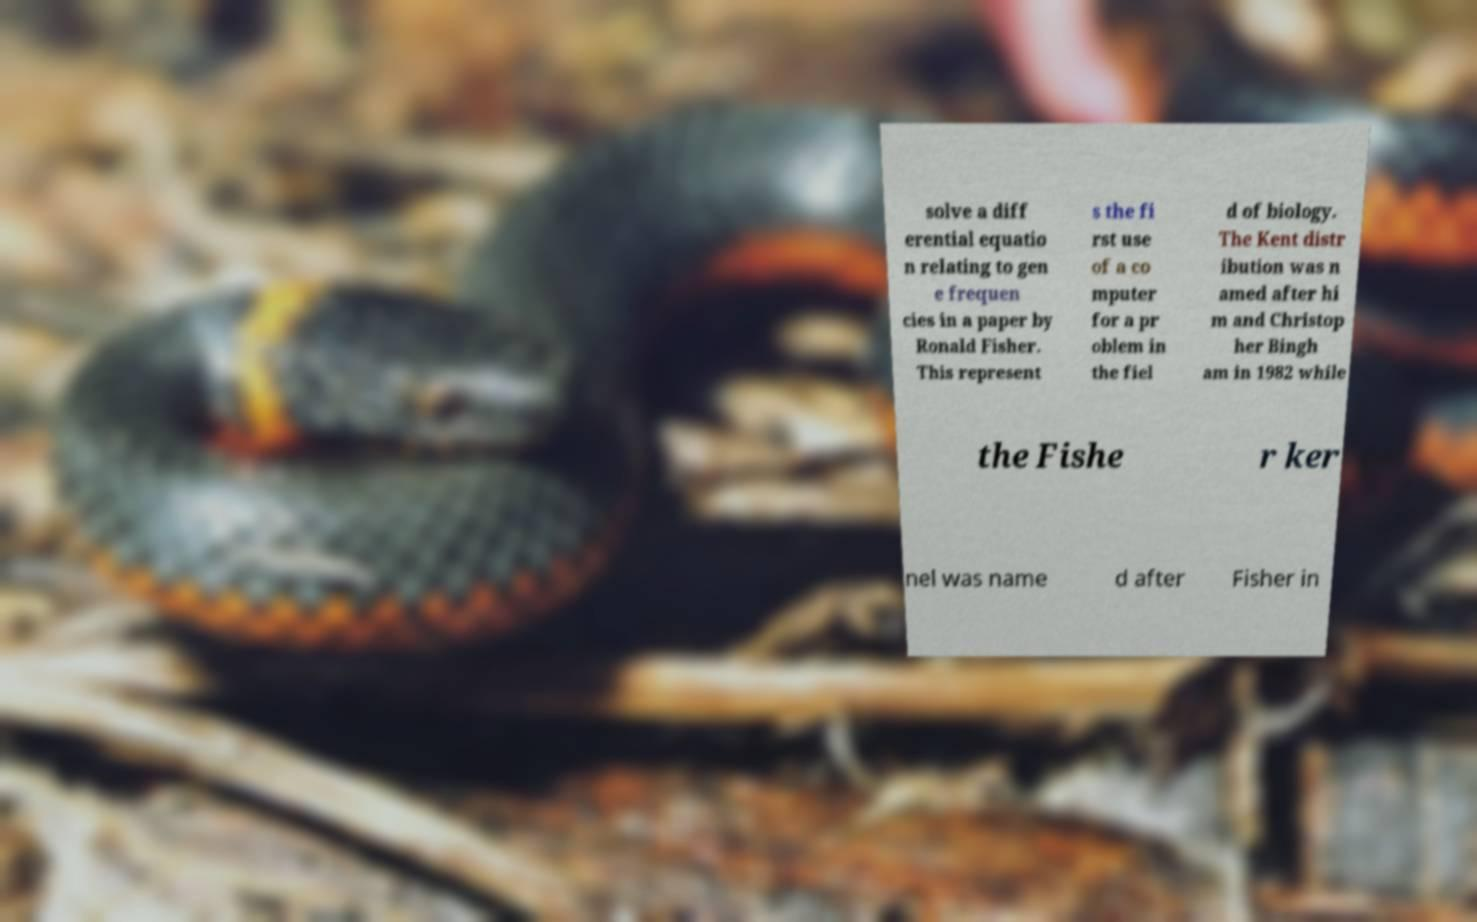Can you read and provide the text displayed in the image?This photo seems to have some interesting text. Can you extract and type it out for me? solve a diff erential equatio n relating to gen e frequen cies in a paper by Ronald Fisher. This represent s the fi rst use of a co mputer for a pr oblem in the fiel d of biology. The Kent distr ibution was n amed after hi m and Christop her Bingh am in 1982 while the Fishe r ker nel was name d after Fisher in 